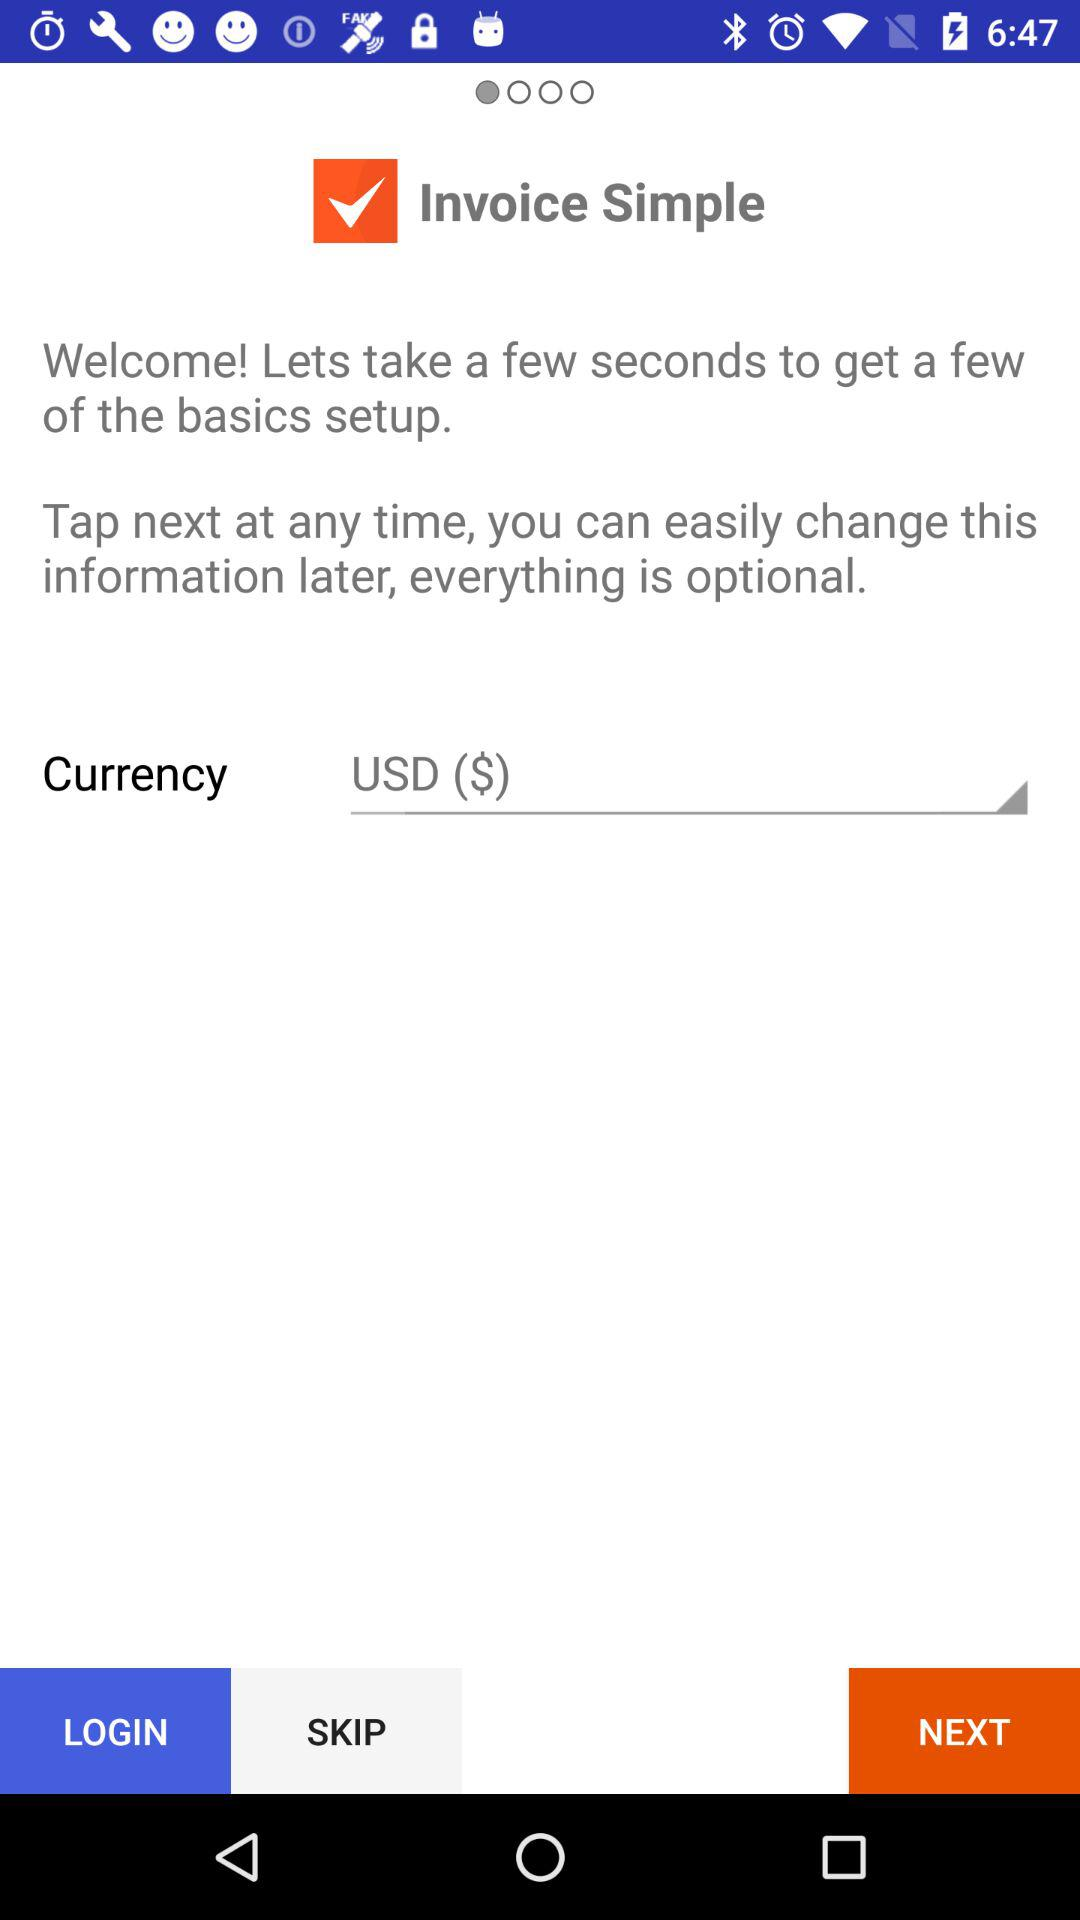What is the application name? The application name is "Invoice Simple". 